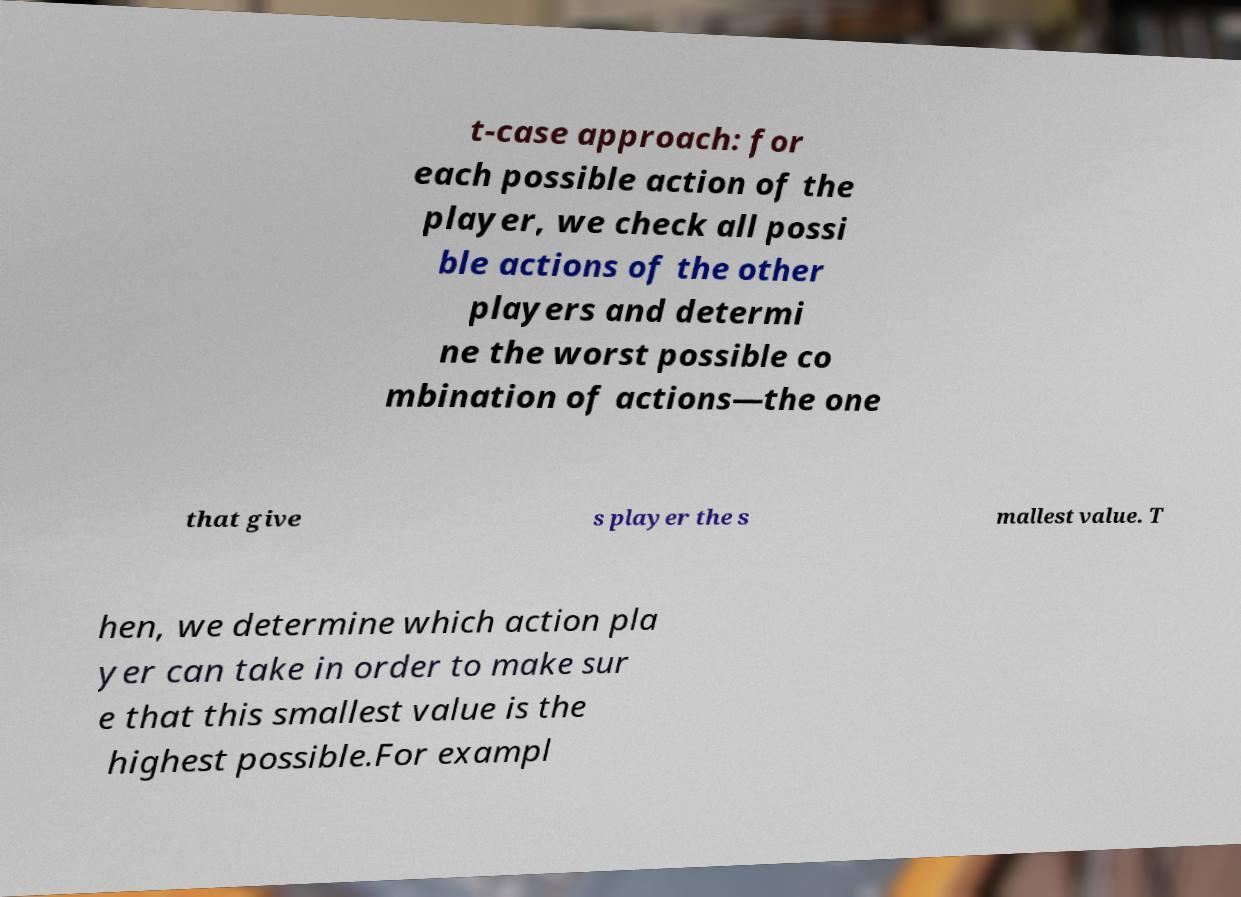For documentation purposes, I need the text within this image transcribed. Could you provide that? t-case approach: for each possible action of the player, we check all possi ble actions of the other players and determi ne the worst possible co mbination of actions—the one that give s player the s mallest value. T hen, we determine which action pla yer can take in order to make sur e that this smallest value is the highest possible.For exampl 